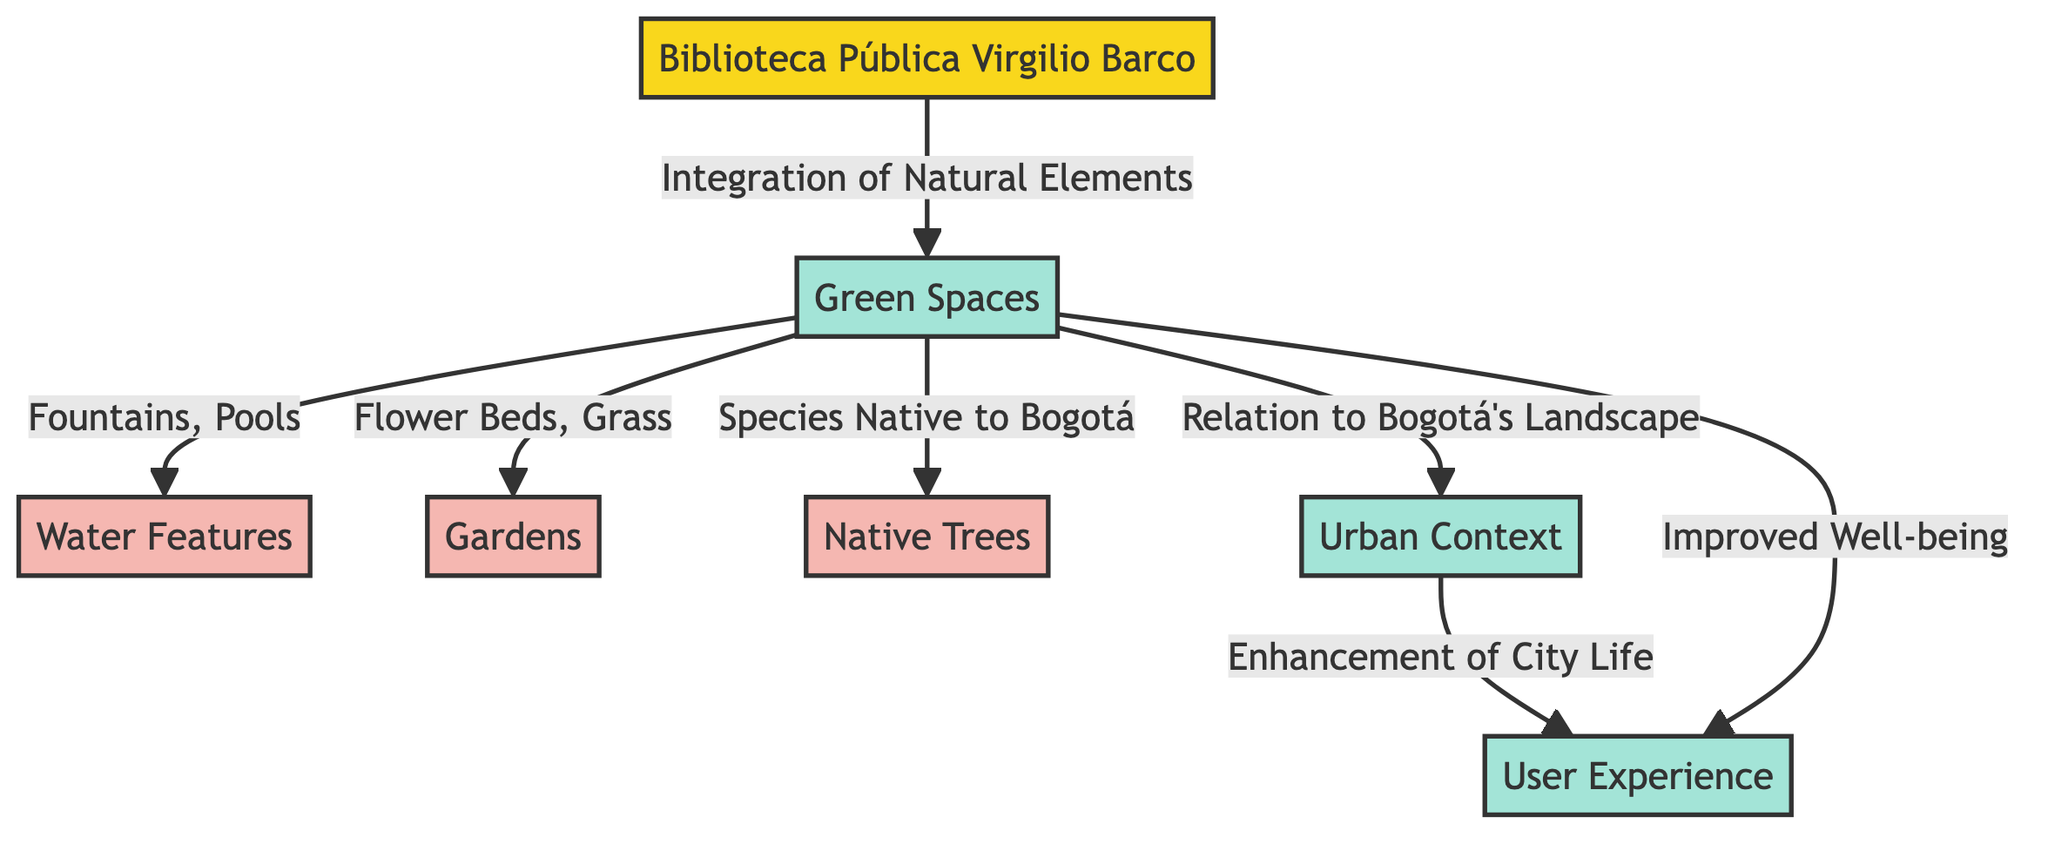What is the main building represented in the diagram? The diagram clearly shows "Biblioteca Pública Virgilio Barco" as the main building. It is indicated by the node labeled biblioteca.
Answer: Biblioteca Pública Virgilio Barco How many types of green spaces are identified in the diagram? The diagram features three types of green spaces: water features, gardens, and native trees. Therefore, by counting each distinct type connected to greenSpaces, we find three.
Answer: 3 Which natural element is specifically mentioned as being native to Bogotá? The diagram indicates that the green space element concerning "Species Native to Bogotá" is represented as trees. Therefore, the answer is trees.
Answer: Trees What is one aspect that enhances city life according to the diagram? The diagram shows that the relationship between the urban context and user experience enhances city life, specifically linked through the urban context arrow pointing to user experience with the description "Enhancement of City Life".
Answer: Enhancement of City Life What two types of features fall under green spaces? According to the diagram, under green spaces, the two types identified are "Fountains, Pools" and "Flower Beds, Grass", both connected to the greenSpaces node.
Answer: Fountains, Pools and Flower Beds, Grass What type of user experience is improved through natural elements? The diagram states that "Improved Well-being" is a specific user experience linked to green spaces as it highlights the positive impact of integrating natural elements.
Answer: Improved Well-being What connects green spaces to the urban context in the flowchart? The arrow labeled "Relation to Bogotá's Landscape" connects the greenSpaces node to the urbanContext node, indicating this relationship as a means of integration.
Answer: Relation to Bogotá's Landscape What are the main concepts illustrated in the diagram? The main concepts illustrated in the diagram include green spaces, urban context, and user experience, all connected to the Biblioteca Pública Virgilio Barco. By identifying the labeled nodes, these three concepts stand out as fundamental themes.
Answer: Green spaces, urban context, and user experience 